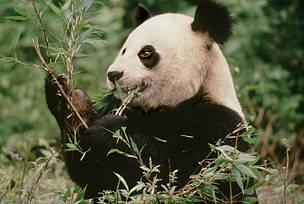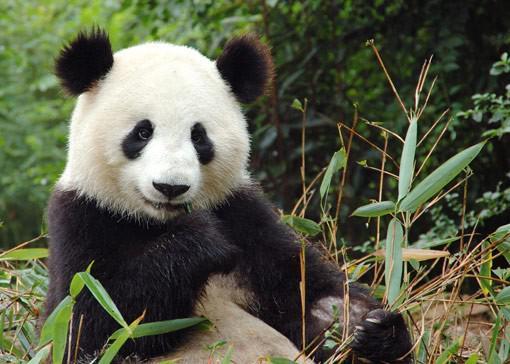The first image is the image on the left, the second image is the image on the right. Assess this claim about the two images: "There are four pandas and a large panda's head is next to a smaller panda's head in at least one of the images.". Correct or not? Answer yes or no. No. The first image is the image on the left, the second image is the image on the right. For the images displayed, is the sentence "there is exactly one panda in the image on the right." factually correct? Answer yes or no. Yes. 